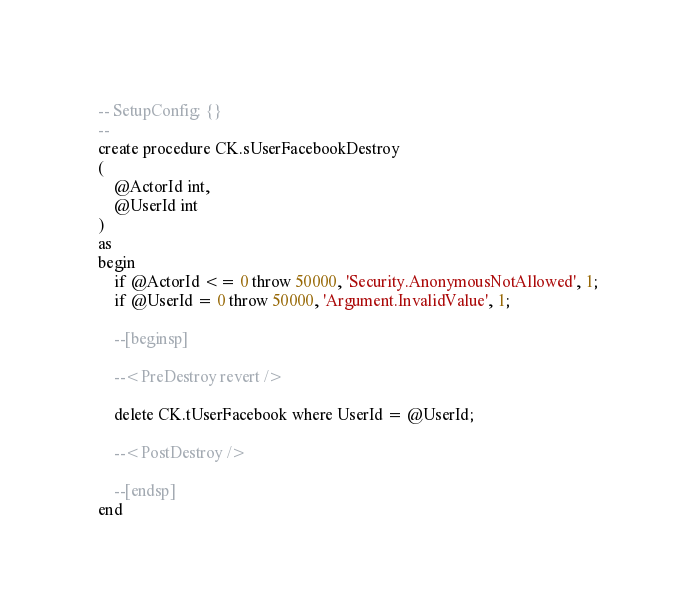<code> <loc_0><loc_0><loc_500><loc_500><_SQL_>-- SetupConfig: {}
--
create procedure CK.sUserFacebookDestroy
(
	@ActorId int,
	@UserId int
)
as
begin
    if @ActorId <= 0 throw 50000, 'Security.AnonymousNotAllowed', 1;
    if @UserId = 0 throw 50000, 'Argument.InvalidValue', 1;

	--[beginsp]

	--<PreDestroy revert /> 
	
	delete CK.tUserFacebook where UserId = @UserId;

	--<PostDestroy /> 

	--[endsp]
end
</code> 